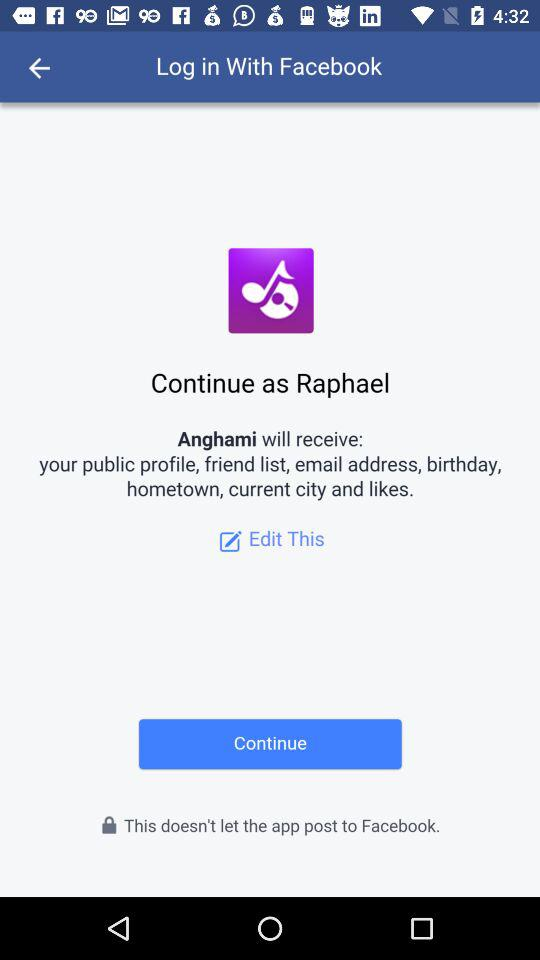What is the name of the application that can be used to log in? The name of the application that can be used to log in is "Facebook". 